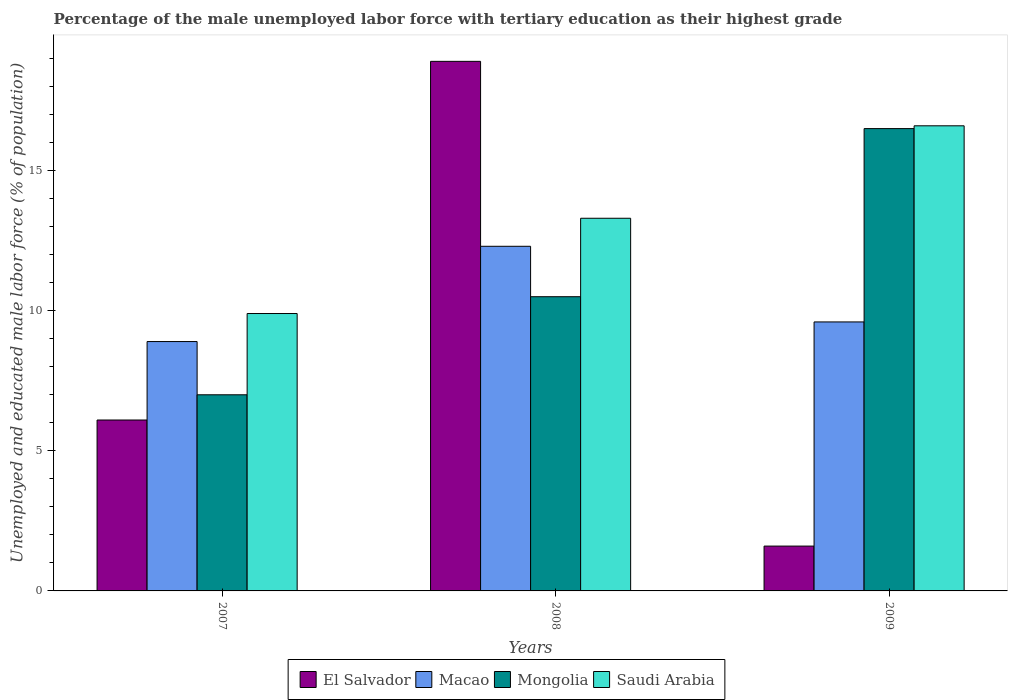How many different coloured bars are there?
Provide a short and direct response. 4. Are the number of bars on each tick of the X-axis equal?
Your answer should be compact. Yes. How many bars are there on the 3rd tick from the left?
Your answer should be compact. 4. How many bars are there on the 3rd tick from the right?
Make the answer very short. 4. What is the label of the 1st group of bars from the left?
Keep it short and to the point. 2007. In how many cases, is the number of bars for a given year not equal to the number of legend labels?
Your response must be concise. 0. Across all years, what is the maximum percentage of the unemployed male labor force with tertiary education in Saudi Arabia?
Keep it short and to the point. 16.6. Across all years, what is the minimum percentage of the unemployed male labor force with tertiary education in Saudi Arabia?
Provide a short and direct response. 9.9. What is the total percentage of the unemployed male labor force with tertiary education in Saudi Arabia in the graph?
Your answer should be compact. 39.8. What is the difference between the percentage of the unemployed male labor force with tertiary education in El Salvador in 2008 and that in 2009?
Provide a short and direct response. 17.3. What is the difference between the percentage of the unemployed male labor force with tertiary education in Macao in 2007 and the percentage of the unemployed male labor force with tertiary education in Saudi Arabia in 2008?
Offer a terse response. -4.4. What is the average percentage of the unemployed male labor force with tertiary education in Mongolia per year?
Your response must be concise. 11.33. In the year 2009, what is the difference between the percentage of the unemployed male labor force with tertiary education in El Salvador and percentage of the unemployed male labor force with tertiary education in Macao?
Your answer should be very brief. -8. In how many years, is the percentage of the unemployed male labor force with tertiary education in Macao greater than 5 %?
Your answer should be compact. 3. What is the ratio of the percentage of the unemployed male labor force with tertiary education in Mongolia in 2008 to that in 2009?
Provide a short and direct response. 0.64. Is the percentage of the unemployed male labor force with tertiary education in Saudi Arabia in 2007 less than that in 2009?
Your answer should be very brief. Yes. Is the difference between the percentage of the unemployed male labor force with tertiary education in El Salvador in 2007 and 2009 greater than the difference between the percentage of the unemployed male labor force with tertiary education in Macao in 2007 and 2009?
Make the answer very short. Yes. What is the difference between the highest and the second highest percentage of the unemployed male labor force with tertiary education in Macao?
Give a very brief answer. 2.7. What is the difference between the highest and the lowest percentage of the unemployed male labor force with tertiary education in Macao?
Your answer should be compact. 3.4. In how many years, is the percentage of the unemployed male labor force with tertiary education in Mongolia greater than the average percentage of the unemployed male labor force with tertiary education in Mongolia taken over all years?
Provide a short and direct response. 1. Is the sum of the percentage of the unemployed male labor force with tertiary education in Macao in 2007 and 2008 greater than the maximum percentage of the unemployed male labor force with tertiary education in El Salvador across all years?
Offer a terse response. Yes. What does the 1st bar from the left in 2008 represents?
Give a very brief answer. El Salvador. What does the 4th bar from the right in 2008 represents?
Offer a very short reply. El Salvador. Are all the bars in the graph horizontal?
Ensure brevity in your answer.  No. How many years are there in the graph?
Give a very brief answer. 3. Are the values on the major ticks of Y-axis written in scientific E-notation?
Offer a very short reply. No. Does the graph contain any zero values?
Offer a terse response. No. Does the graph contain grids?
Keep it short and to the point. No. What is the title of the graph?
Keep it short and to the point. Percentage of the male unemployed labor force with tertiary education as their highest grade. Does "St. Martin (French part)" appear as one of the legend labels in the graph?
Ensure brevity in your answer.  No. What is the label or title of the Y-axis?
Ensure brevity in your answer.  Unemployed and educated male labor force (% of population). What is the Unemployed and educated male labor force (% of population) in El Salvador in 2007?
Your response must be concise. 6.1. What is the Unemployed and educated male labor force (% of population) of Macao in 2007?
Give a very brief answer. 8.9. What is the Unemployed and educated male labor force (% of population) in Mongolia in 2007?
Your response must be concise. 7. What is the Unemployed and educated male labor force (% of population) in Saudi Arabia in 2007?
Ensure brevity in your answer.  9.9. What is the Unemployed and educated male labor force (% of population) of El Salvador in 2008?
Provide a short and direct response. 18.9. What is the Unemployed and educated male labor force (% of population) of Macao in 2008?
Your answer should be very brief. 12.3. What is the Unemployed and educated male labor force (% of population) of Mongolia in 2008?
Your response must be concise. 10.5. What is the Unemployed and educated male labor force (% of population) in Saudi Arabia in 2008?
Offer a very short reply. 13.3. What is the Unemployed and educated male labor force (% of population) of El Salvador in 2009?
Offer a terse response. 1.6. What is the Unemployed and educated male labor force (% of population) in Macao in 2009?
Provide a short and direct response. 9.6. What is the Unemployed and educated male labor force (% of population) in Mongolia in 2009?
Provide a short and direct response. 16.5. What is the Unemployed and educated male labor force (% of population) of Saudi Arabia in 2009?
Provide a succinct answer. 16.6. Across all years, what is the maximum Unemployed and educated male labor force (% of population) of El Salvador?
Your response must be concise. 18.9. Across all years, what is the maximum Unemployed and educated male labor force (% of population) in Macao?
Give a very brief answer. 12.3. Across all years, what is the maximum Unemployed and educated male labor force (% of population) in Saudi Arabia?
Keep it short and to the point. 16.6. Across all years, what is the minimum Unemployed and educated male labor force (% of population) in El Salvador?
Offer a terse response. 1.6. Across all years, what is the minimum Unemployed and educated male labor force (% of population) in Macao?
Ensure brevity in your answer.  8.9. Across all years, what is the minimum Unemployed and educated male labor force (% of population) of Mongolia?
Offer a terse response. 7. Across all years, what is the minimum Unemployed and educated male labor force (% of population) of Saudi Arabia?
Ensure brevity in your answer.  9.9. What is the total Unemployed and educated male labor force (% of population) of El Salvador in the graph?
Give a very brief answer. 26.6. What is the total Unemployed and educated male labor force (% of population) of Macao in the graph?
Your answer should be compact. 30.8. What is the total Unemployed and educated male labor force (% of population) of Saudi Arabia in the graph?
Your answer should be very brief. 39.8. What is the difference between the Unemployed and educated male labor force (% of population) in El Salvador in 2007 and that in 2008?
Offer a terse response. -12.8. What is the difference between the Unemployed and educated male labor force (% of population) in Macao in 2007 and that in 2008?
Your response must be concise. -3.4. What is the difference between the Unemployed and educated male labor force (% of population) in Macao in 2007 and that in 2009?
Your response must be concise. -0.7. What is the difference between the Unemployed and educated male labor force (% of population) in El Salvador in 2008 and that in 2009?
Make the answer very short. 17.3. What is the difference between the Unemployed and educated male labor force (% of population) in Mongolia in 2008 and that in 2009?
Provide a short and direct response. -6. What is the difference between the Unemployed and educated male labor force (% of population) in Saudi Arabia in 2008 and that in 2009?
Provide a succinct answer. -3.3. What is the difference between the Unemployed and educated male labor force (% of population) of El Salvador in 2007 and the Unemployed and educated male labor force (% of population) of Macao in 2008?
Your answer should be very brief. -6.2. What is the difference between the Unemployed and educated male labor force (% of population) in El Salvador in 2007 and the Unemployed and educated male labor force (% of population) in Mongolia in 2008?
Keep it short and to the point. -4.4. What is the difference between the Unemployed and educated male labor force (% of population) in El Salvador in 2007 and the Unemployed and educated male labor force (% of population) in Saudi Arabia in 2008?
Your answer should be compact. -7.2. What is the difference between the Unemployed and educated male labor force (% of population) of Mongolia in 2007 and the Unemployed and educated male labor force (% of population) of Saudi Arabia in 2008?
Ensure brevity in your answer.  -6.3. What is the difference between the Unemployed and educated male labor force (% of population) of Macao in 2007 and the Unemployed and educated male labor force (% of population) of Mongolia in 2009?
Offer a terse response. -7.6. What is the difference between the Unemployed and educated male labor force (% of population) of Mongolia in 2007 and the Unemployed and educated male labor force (% of population) of Saudi Arabia in 2009?
Make the answer very short. -9.6. What is the difference between the Unemployed and educated male labor force (% of population) in El Salvador in 2008 and the Unemployed and educated male labor force (% of population) in Macao in 2009?
Provide a short and direct response. 9.3. What is the difference between the Unemployed and educated male labor force (% of population) in El Salvador in 2008 and the Unemployed and educated male labor force (% of population) in Mongolia in 2009?
Make the answer very short. 2.4. What is the difference between the Unemployed and educated male labor force (% of population) of Macao in 2008 and the Unemployed and educated male labor force (% of population) of Mongolia in 2009?
Provide a succinct answer. -4.2. What is the average Unemployed and educated male labor force (% of population) in El Salvador per year?
Keep it short and to the point. 8.87. What is the average Unemployed and educated male labor force (% of population) in Macao per year?
Keep it short and to the point. 10.27. What is the average Unemployed and educated male labor force (% of population) in Mongolia per year?
Offer a very short reply. 11.33. What is the average Unemployed and educated male labor force (% of population) of Saudi Arabia per year?
Provide a succinct answer. 13.27. In the year 2007, what is the difference between the Unemployed and educated male labor force (% of population) of El Salvador and Unemployed and educated male labor force (% of population) of Macao?
Give a very brief answer. -2.8. In the year 2007, what is the difference between the Unemployed and educated male labor force (% of population) in El Salvador and Unemployed and educated male labor force (% of population) in Mongolia?
Offer a very short reply. -0.9. In the year 2007, what is the difference between the Unemployed and educated male labor force (% of population) of Macao and Unemployed and educated male labor force (% of population) of Mongolia?
Ensure brevity in your answer.  1.9. In the year 2008, what is the difference between the Unemployed and educated male labor force (% of population) of El Salvador and Unemployed and educated male labor force (% of population) of Macao?
Provide a short and direct response. 6.6. In the year 2008, what is the difference between the Unemployed and educated male labor force (% of population) in El Salvador and Unemployed and educated male labor force (% of population) in Saudi Arabia?
Make the answer very short. 5.6. In the year 2008, what is the difference between the Unemployed and educated male labor force (% of population) of Macao and Unemployed and educated male labor force (% of population) of Mongolia?
Give a very brief answer. 1.8. In the year 2008, what is the difference between the Unemployed and educated male labor force (% of population) of Mongolia and Unemployed and educated male labor force (% of population) of Saudi Arabia?
Ensure brevity in your answer.  -2.8. In the year 2009, what is the difference between the Unemployed and educated male labor force (% of population) of El Salvador and Unemployed and educated male labor force (% of population) of Mongolia?
Ensure brevity in your answer.  -14.9. In the year 2009, what is the difference between the Unemployed and educated male labor force (% of population) in El Salvador and Unemployed and educated male labor force (% of population) in Saudi Arabia?
Your answer should be compact. -15. In the year 2009, what is the difference between the Unemployed and educated male labor force (% of population) in Macao and Unemployed and educated male labor force (% of population) in Mongolia?
Give a very brief answer. -6.9. What is the ratio of the Unemployed and educated male labor force (% of population) in El Salvador in 2007 to that in 2008?
Make the answer very short. 0.32. What is the ratio of the Unemployed and educated male labor force (% of population) of Macao in 2007 to that in 2008?
Offer a terse response. 0.72. What is the ratio of the Unemployed and educated male labor force (% of population) of Mongolia in 2007 to that in 2008?
Give a very brief answer. 0.67. What is the ratio of the Unemployed and educated male labor force (% of population) in Saudi Arabia in 2007 to that in 2008?
Ensure brevity in your answer.  0.74. What is the ratio of the Unemployed and educated male labor force (% of population) of El Salvador in 2007 to that in 2009?
Offer a terse response. 3.81. What is the ratio of the Unemployed and educated male labor force (% of population) in Macao in 2007 to that in 2009?
Offer a terse response. 0.93. What is the ratio of the Unemployed and educated male labor force (% of population) in Mongolia in 2007 to that in 2009?
Your response must be concise. 0.42. What is the ratio of the Unemployed and educated male labor force (% of population) in Saudi Arabia in 2007 to that in 2009?
Your response must be concise. 0.6. What is the ratio of the Unemployed and educated male labor force (% of population) of El Salvador in 2008 to that in 2009?
Give a very brief answer. 11.81. What is the ratio of the Unemployed and educated male labor force (% of population) in Macao in 2008 to that in 2009?
Your response must be concise. 1.28. What is the ratio of the Unemployed and educated male labor force (% of population) in Mongolia in 2008 to that in 2009?
Your answer should be very brief. 0.64. What is the ratio of the Unemployed and educated male labor force (% of population) of Saudi Arabia in 2008 to that in 2009?
Offer a very short reply. 0.8. What is the difference between the highest and the second highest Unemployed and educated male labor force (% of population) in Macao?
Give a very brief answer. 2.7. What is the difference between the highest and the lowest Unemployed and educated male labor force (% of population) of El Salvador?
Your response must be concise. 17.3. What is the difference between the highest and the lowest Unemployed and educated male labor force (% of population) in Saudi Arabia?
Make the answer very short. 6.7. 